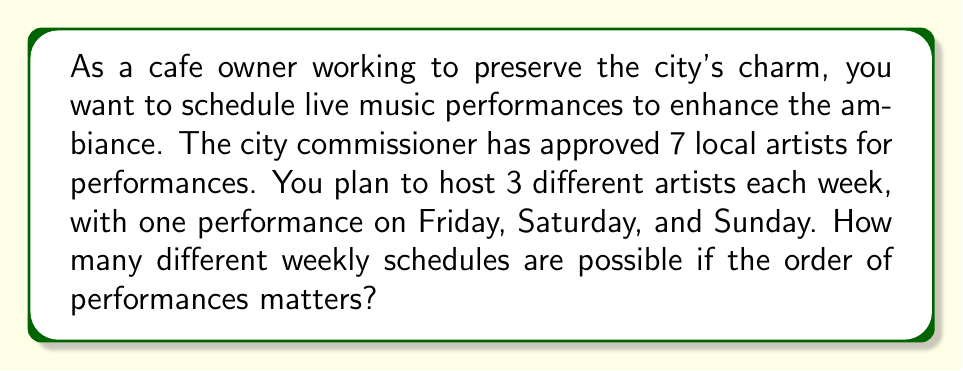Provide a solution to this math problem. Let's approach this step-by-step:

1) We need to select 3 artists out of 7 for the week's performances.

2) The order matters because we're assigning specific days (Friday, Saturday, Sunday) to each artist.

3) This scenario is a permutation problem. We're selecting 3 artists from 7, where the order matters.

4) The formula for permutations is:

   $$P(n,r) = \frac{n!}{(n-r)!}$$

   Where $n$ is the total number of items to choose from, and $r$ is the number of items being chosen.

5) In this case, $n = 7$ (total artists) and $r = 3$ (artists performing each week).

6) Plugging these values into the formula:

   $$P(7,3) = \frac{7!}{(7-3)!} = \frac{7!}{4!}$$

7) Expanding this:
   
   $$\frac{7 \times 6 \times 5 \times 4!}{4!}$$

8) The $4!$ cancels out in the numerator and denominator:

   $$7 \times 6 \times 5 = 210$$

Therefore, there are 210 possible weekly schedules for the live music performances.
Answer: 210 possible weekly schedules 